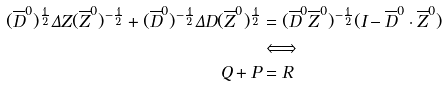<formula> <loc_0><loc_0><loc_500><loc_500>( \overline { D } ^ { 0 } ) ^ { \frac { 1 } { 2 } } \Delta Z ( \overline { Z } ^ { 0 } ) ^ { - \frac { 1 } { 2 } } + ( \overline { D } ^ { 0 } ) ^ { - \frac { 1 } { 2 } } \Delta D ( \overline { Z } ^ { 0 } ) ^ { \frac { 1 } { 2 } } & = ( \overline { D } ^ { 0 } \overline { Z } ^ { 0 } ) ^ { - \frac { 1 } { 2 } } ( I - \overline { D } ^ { 0 } \cdot \overline { Z } ^ { 0 } ) \\ & \Longleftrightarrow \\ Q + P & = R</formula> 